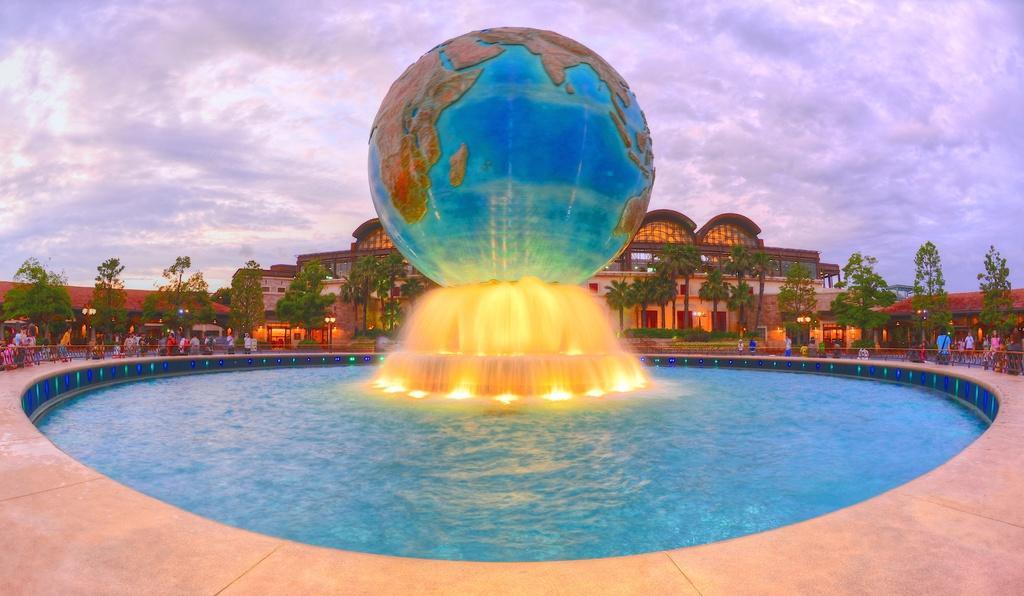Describe this image in one or two sentences. In this picture I can see there is a fountain, there is a globe on it, there is some water, there is a fence around it, there are a few people standing around it and there are trees in the backdrop and there is a building and the sky is clear. 